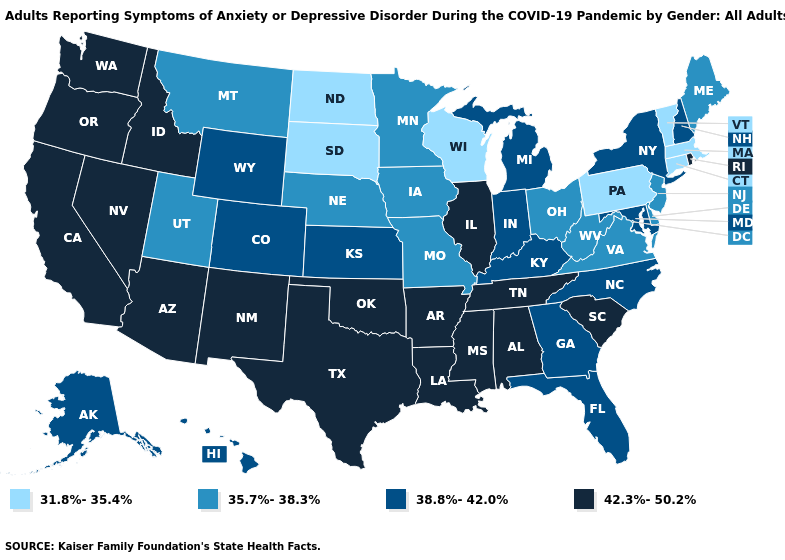Which states have the lowest value in the USA?
Keep it brief. Connecticut, Massachusetts, North Dakota, Pennsylvania, South Dakota, Vermont, Wisconsin. Is the legend a continuous bar?
Short answer required. No. What is the highest value in the USA?
Keep it brief. 42.3%-50.2%. Which states have the lowest value in the Northeast?
Be succinct. Connecticut, Massachusetts, Pennsylvania, Vermont. What is the value of Oregon?
Answer briefly. 42.3%-50.2%. Does the first symbol in the legend represent the smallest category?
Give a very brief answer. Yes. Does Pennsylvania have a higher value than Oregon?
Short answer required. No. Name the states that have a value in the range 35.7%-38.3%?
Keep it brief. Delaware, Iowa, Maine, Minnesota, Missouri, Montana, Nebraska, New Jersey, Ohio, Utah, Virginia, West Virginia. Which states have the highest value in the USA?
Concise answer only. Alabama, Arizona, Arkansas, California, Idaho, Illinois, Louisiana, Mississippi, Nevada, New Mexico, Oklahoma, Oregon, Rhode Island, South Carolina, Tennessee, Texas, Washington. How many symbols are there in the legend?
Write a very short answer. 4. What is the highest value in the MidWest ?
Short answer required. 42.3%-50.2%. What is the value of West Virginia?
Short answer required. 35.7%-38.3%. Does Connecticut have the lowest value in the USA?
Give a very brief answer. Yes. Does Idaho have a higher value than Arkansas?
Write a very short answer. No. Does Arizona have a higher value than Minnesota?
Write a very short answer. Yes. 